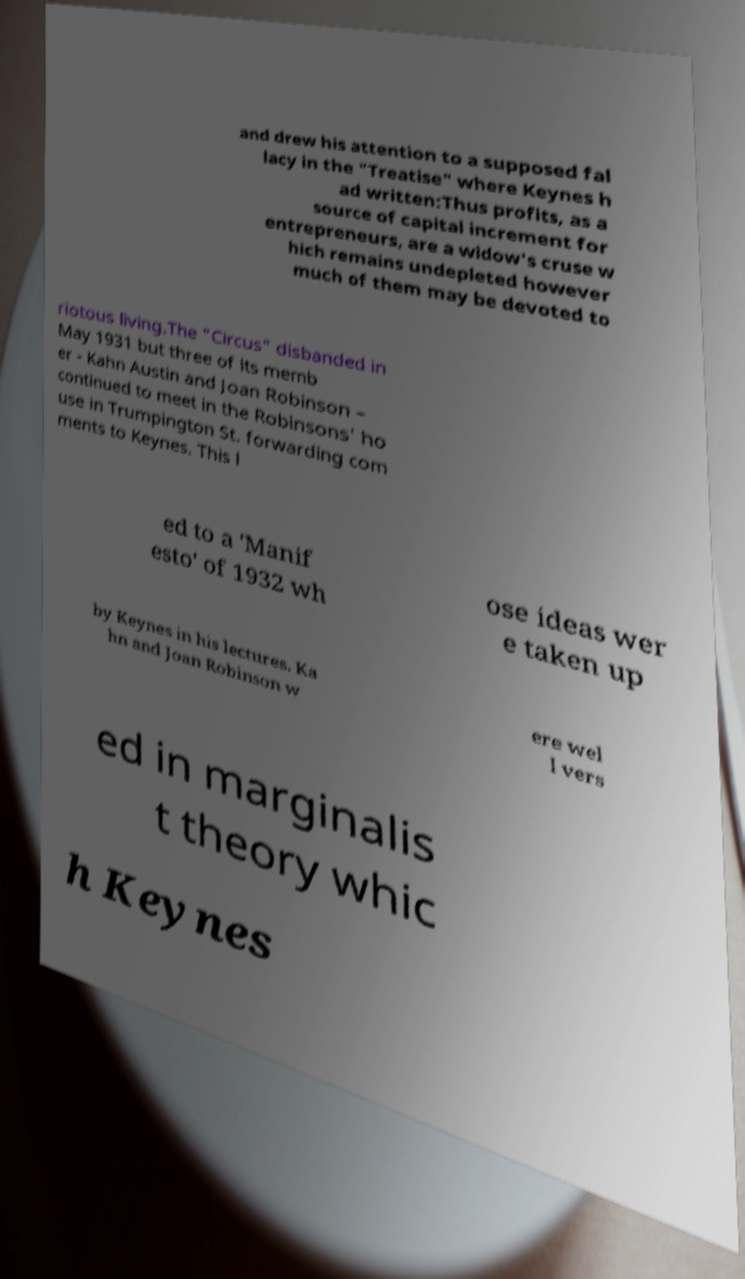I need the written content from this picture converted into text. Can you do that? and drew his attention to a supposed fal lacy in the "Treatise" where Keynes h ad written:Thus profits, as a source of capital increment for entrepreneurs, are a widow's cruse w hich remains undepleted however much of them may be devoted to riotous living.The "Circus" disbanded in May 1931 but three of its memb er - Kahn Austin and Joan Robinson – continued to meet in the Robinsons' ho use in Trumpington St. forwarding com ments to Keynes. This l ed to a 'Manif esto' of 1932 wh ose ideas wer e taken up by Keynes in his lectures. Ka hn and Joan Robinson w ere wel l vers ed in marginalis t theory whic h Keynes 